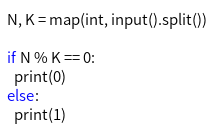<code> <loc_0><loc_0><loc_500><loc_500><_Python_>N, K = map(int, input().split())

if N % K == 0:
  print(0)
else:
  print(1)</code> 